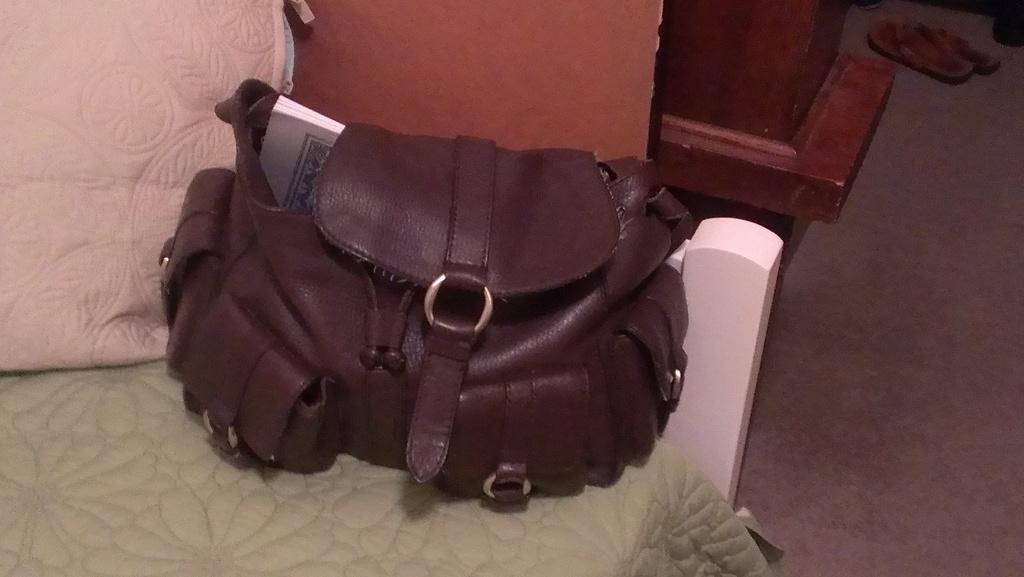What type of accessory is in the image? There is a brown handbag in the image. Where is the handbag located? The handbag is on a table. What can be seen on the floor in the image? There are slippers visible on the floor. What color is the nail sticking out of the handbag in the image? There is no nail sticking out of the handbag in the image. 